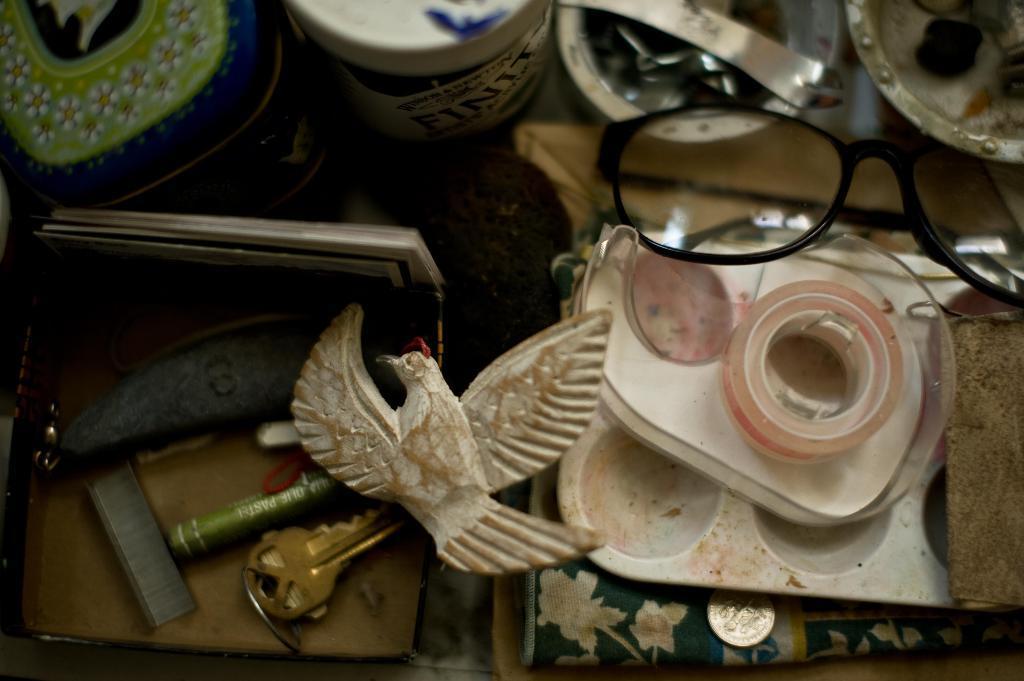How would you summarize this image in a sentence or two? In this picture we can see spectacles, boxes, staples, key, plaster and few other things. 